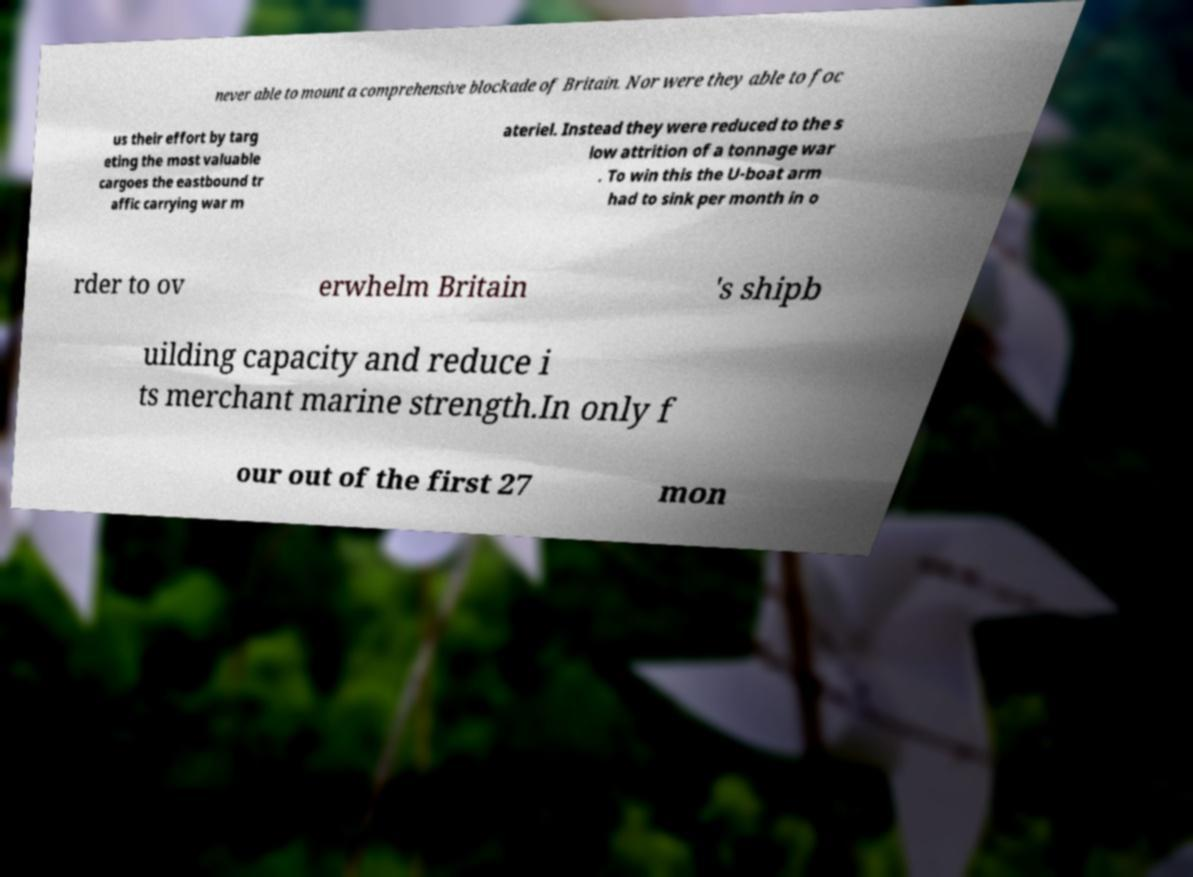Could you extract and type out the text from this image? never able to mount a comprehensive blockade of Britain. Nor were they able to foc us their effort by targ eting the most valuable cargoes the eastbound tr affic carrying war m ateriel. Instead they were reduced to the s low attrition of a tonnage war . To win this the U-boat arm had to sink per month in o rder to ov erwhelm Britain 's shipb uilding capacity and reduce i ts merchant marine strength.In only f our out of the first 27 mon 